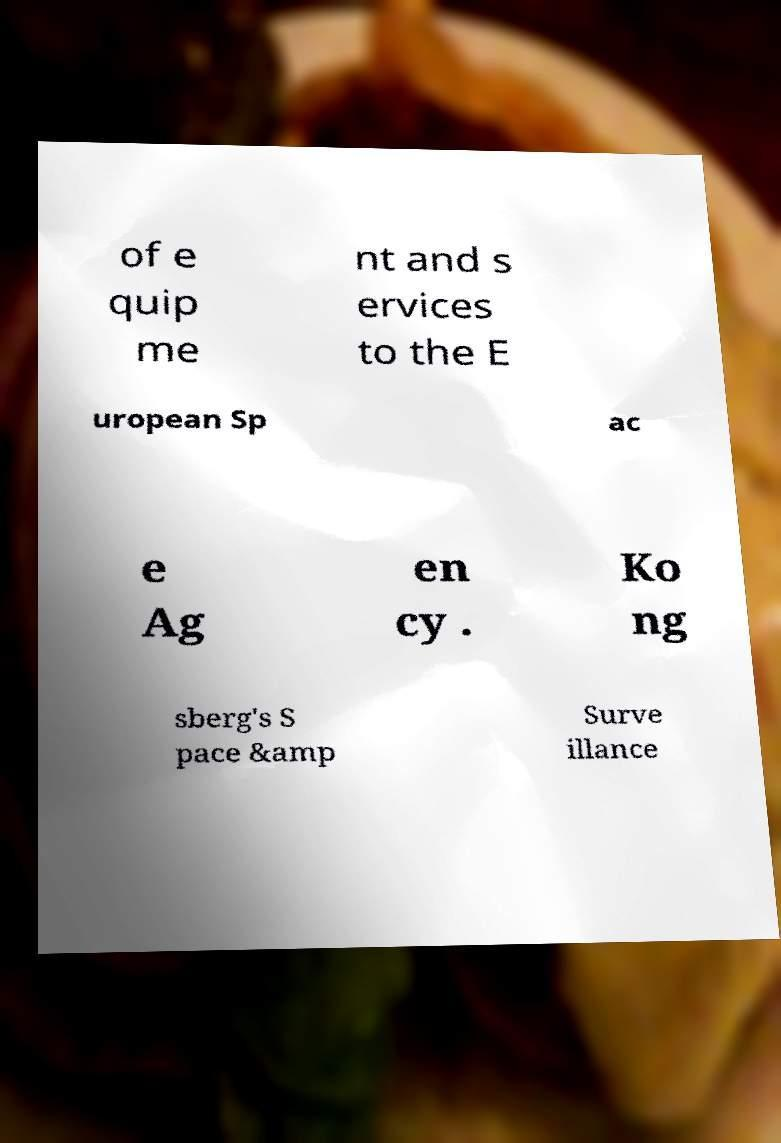What messages or text are displayed in this image? I need them in a readable, typed format. of e quip me nt and s ervices to the E uropean Sp ac e Ag en cy . Ko ng sberg's S pace &amp Surve illance 